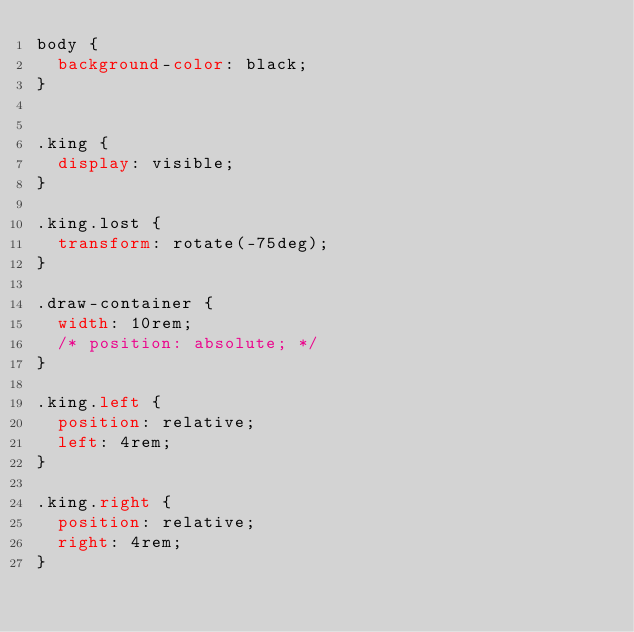Convert code to text. <code><loc_0><loc_0><loc_500><loc_500><_CSS_>body {
  background-color: black;
}


.king {
  display: visible;
}

.king.lost {
  transform: rotate(-75deg);
}

.draw-container {
  width: 10rem;
  /* position: absolute; */
}

.king.left {
  position: relative;
  left: 4rem;
}

.king.right {
  position: relative;
  right: 4rem;
}</code> 